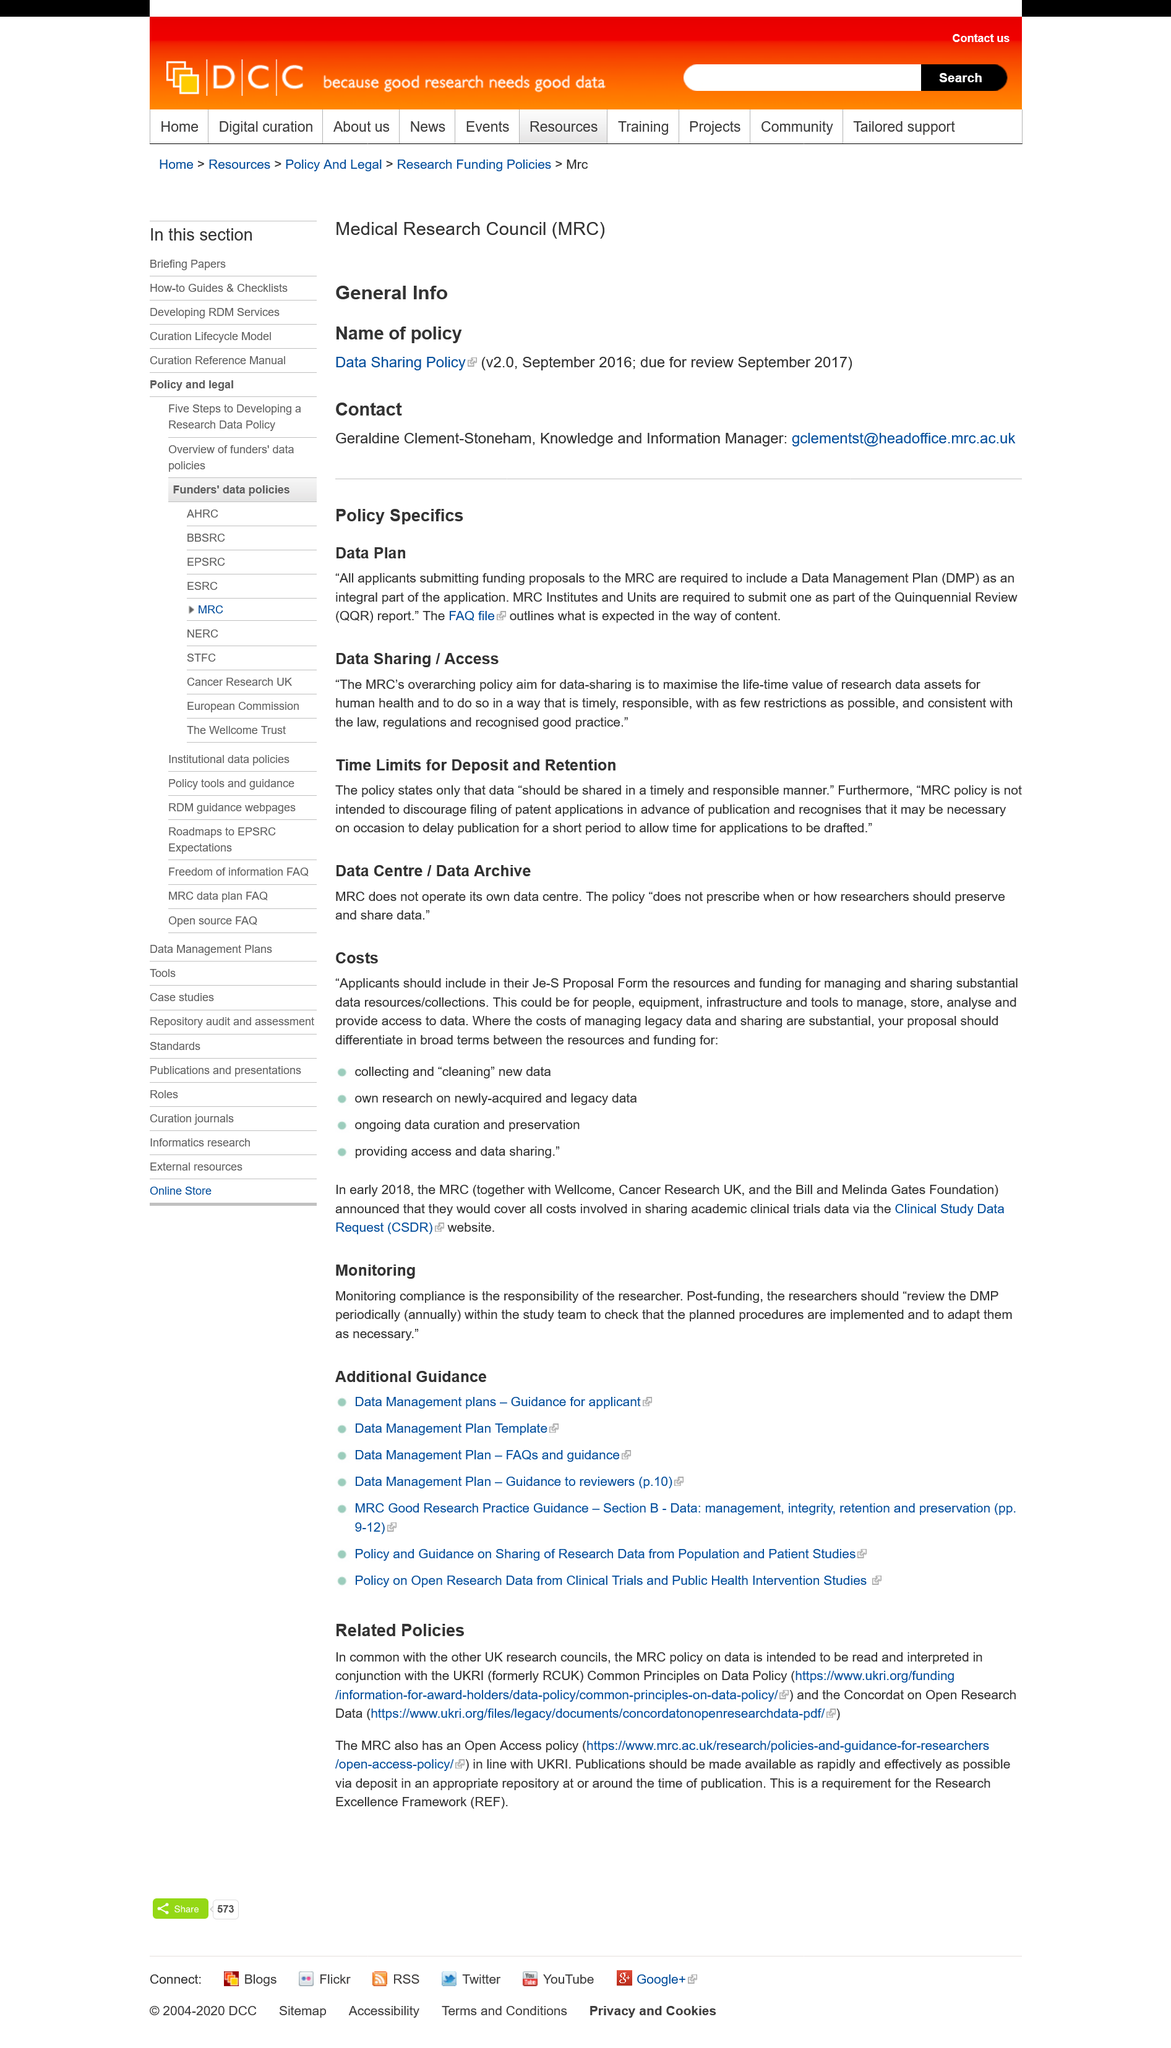Point out several critical features in this image. All applicants submitting funding proposals to the MRC must include a Data Management Plan (DMP) in their application. The Data Management Plan is subject to time limits, which concern the deposit and retention of data. Publication may be delayed to allow for the drafting of applications. 